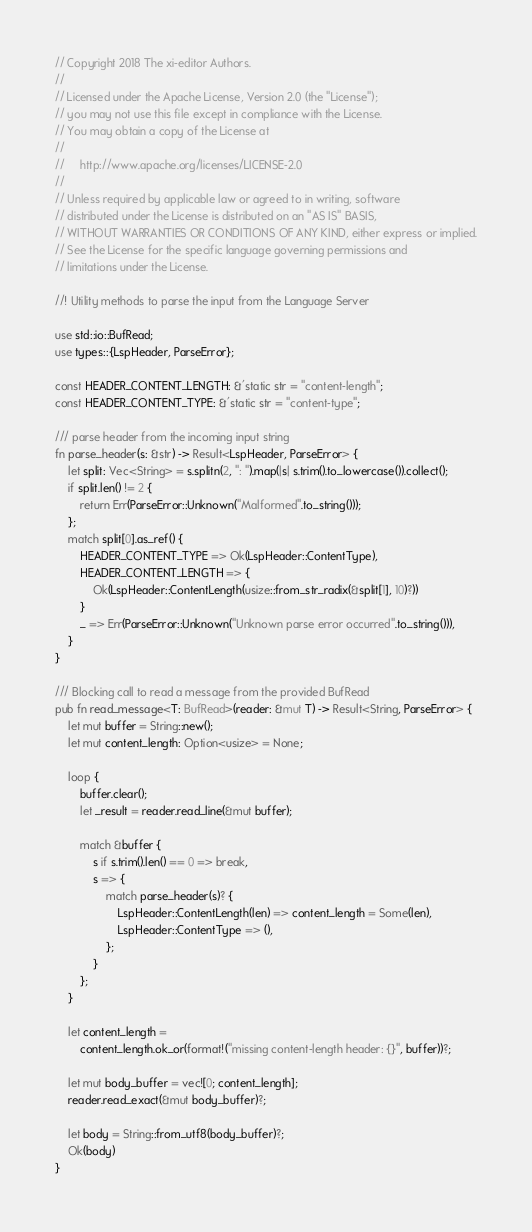<code> <loc_0><loc_0><loc_500><loc_500><_Rust_>// Copyright 2018 The xi-editor Authors.
//
// Licensed under the Apache License, Version 2.0 (the "License");
// you may not use this file except in compliance with the License.
// You may obtain a copy of the License at
//
//     http://www.apache.org/licenses/LICENSE-2.0
//
// Unless required by applicable law or agreed to in writing, software
// distributed under the License is distributed on an "AS IS" BASIS,
// WITHOUT WARRANTIES OR CONDITIONS OF ANY KIND, either express or implied.
// See the License for the specific language governing permissions and
// limitations under the License.

//! Utility methods to parse the input from the Language Server

use std::io::BufRead;
use types::{LspHeader, ParseError};

const HEADER_CONTENT_LENGTH: &'static str = "content-length";
const HEADER_CONTENT_TYPE: &'static str = "content-type";

/// parse header from the incoming input string
fn parse_header(s: &str) -> Result<LspHeader, ParseError> {
    let split: Vec<String> = s.splitn(2, ": ").map(|s| s.trim().to_lowercase()).collect();
    if split.len() != 2 {
        return Err(ParseError::Unknown("Malformed".to_string()));
    };
    match split[0].as_ref() {
        HEADER_CONTENT_TYPE => Ok(LspHeader::ContentType),
        HEADER_CONTENT_LENGTH => {
            Ok(LspHeader::ContentLength(usize::from_str_radix(&split[1], 10)?))
        }
        _ => Err(ParseError::Unknown("Unknown parse error occurred".to_string())),
    }
}

/// Blocking call to read a message from the provided BufRead
pub fn read_message<T: BufRead>(reader: &mut T) -> Result<String, ParseError> {
    let mut buffer = String::new();
    let mut content_length: Option<usize> = None;

    loop {
        buffer.clear();
        let _result = reader.read_line(&mut buffer);

        match &buffer {
            s if s.trim().len() == 0 => break,
            s => {
                match parse_header(s)? {
                    LspHeader::ContentLength(len) => content_length = Some(len),
                    LspHeader::ContentType => (),
                };
            }
        };
    }

    let content_length =
        content_length.ok_or(format!("missing content-length header: {}", buffer))?;

    let mut body_buffer = vec![0; content_length];
    reader.read_exact(&mut body_buffer)?;

    let body = String::from_utf8(body_buffer)?;
    Ok(body)
}
</code> 